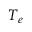<formula> <loc_0><loc_0><loc_500><loc_500>T _ { e }</formula> 